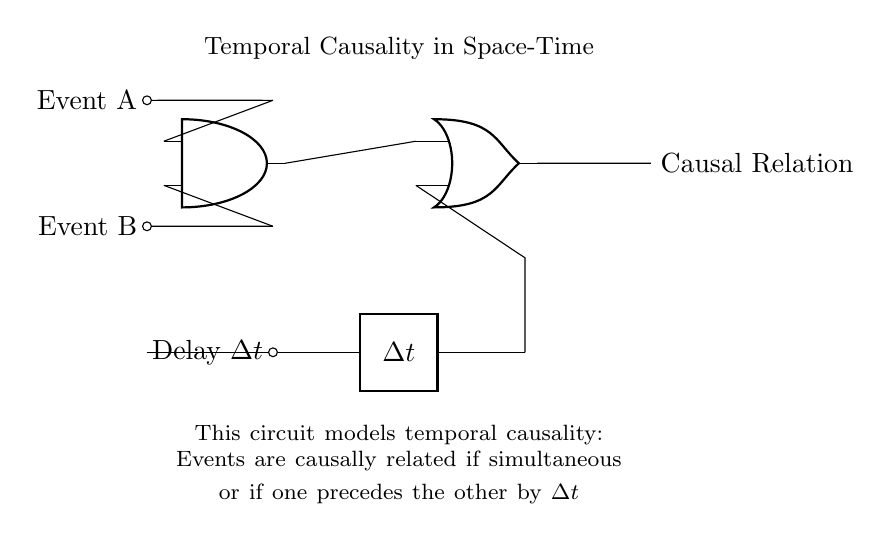What are the input events represented in the circuit? The circuit includes two input events labeled Event A and Event B, which are necessary for the logic gate to process.
Answer: Event A and Event B What type of gate is used to model simultaneous events? The AND gate is specifically designed to output a true signal when both Event A and Event B occur simultaneously, indicating a logical conjunction.
Answer: AND gate What is the function of the OR gate in this circuit? The OR gate combines the output from the AND gate and the delay element, signifying that either the events are simultaneous or there is a temporal causality if they are preceded by delay.
Answer: Causal relation What role does the delay element play in this circuit? The delay element introduces a time difference, represented as Delta t, allowing the OR gate to determine if an event occurs after another by a specific time interval, essential for establishing causality.
Answer: Delay How does the circuit signify causal relation? The causal relation is indicated at the output of the OR gate, asserting that events can be causally linked through simultaneous occurrence or by one event occurring after the other with respect to the delay represented.
Answer: Causal Relation 